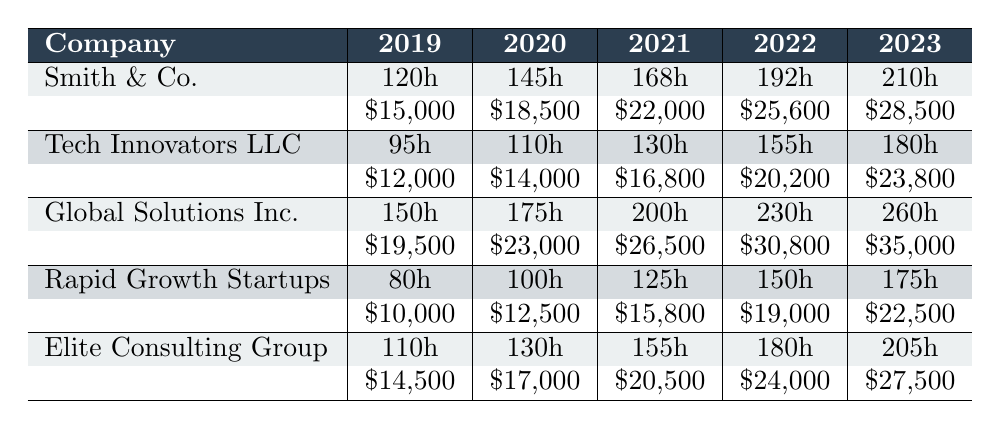What is the productivity loss in hours for Global Solutions Inc. in 2023? According to the table, the productivity loss in hours for Global Solutions Inc. in 2023 is listed as 260 hours.
Answer: 260 hours Which company experienced the highest revenue loss in 2022? The table shows the revenue loss in 2022 for each company, where Global Solutions Inc. had the highest loss of $30,800.
Answer: Global Solutions Inc What was the average productivity loss in hours across all companies for 2021? We find the productivity loss for 2021: Smith & Co. (168), Tech Innovators LLC (130), Global Solutions Inc. (200), Rapid Growth Startups (125), Elite Consulting Group (155). The average is (168 + 130 + 200 + 125 + 155) / 5 = 155.6 hours.
Answer: 155.6 hours Is the client satisfaction score for Tech Innovators LLC in 2020 higher than 8.0? The table lists the client satisfaction score for Tech Innovators LLC in 2020 as 8.3, which is higher than 8.0.
Answer: Yes What is the total employee overtime hours for Rapid Growth Startups from 2019 to 2023? We list the overtime hours from the table: 80 (2019), 100 (2020), 125 (2021), 150 (2022), and 175 (2023). The total is 80 + 100 + 125 + 150 + 175 = 630 hours.
Answer: 630 hours What percentage of appointments were rescheduled by Elite Consulting Group in 2022? The table shows the percentage of rescheduled appointments for Elite Consulting Group in 2022 as 23%.
Answer: 23% Which company's productivity loss increased the most from 2022 to 2023? The productivity loss data shows: Smith & Co. (192 to 210), Tech Innovators LLC (155 to 180), Global Solutions Inc. (230 to 260), Rapid Growth Startups (150 to 175), Elite Consulting Group (180 to 205). The largest increase is for Global Solutions Inc. with an increase of 30 hours.
Answer: Global Solutions Inc Did any company have a consistent decrease in client satisfaction scores from 2019 to 2023? By examining the scores over the years for each company, we see that Global Solutions Inc. has decreased from 7.8 to 6.6, indicating a consistent decline over the years.
Answer: Yes What is the relationship between employee overtime hours and productivity loss for Smith & Co. in 2023? For Smith & Co. in 2023, the productivity loss is 210 hours and employee overtime hours are 150 hours. While both numbers are increasing, the productivity loss is greater than overtime hours.
Answer: Productivity loss is greater than overtime hours What was the total loss in revenue for Tech Innovators LLC from 2019 to 2023? The revenue for Tech Innovators LLC from 2019 to 2023 is: $12,000 (2019), $14,000 (2020), $16,800 (2021), $20,200 (2022), and $23,800 (2023). The total loss is $12,000 + $14,000 + $16,800 + $20,200 + $23,800 = $86,800.
Answer: $86,800 